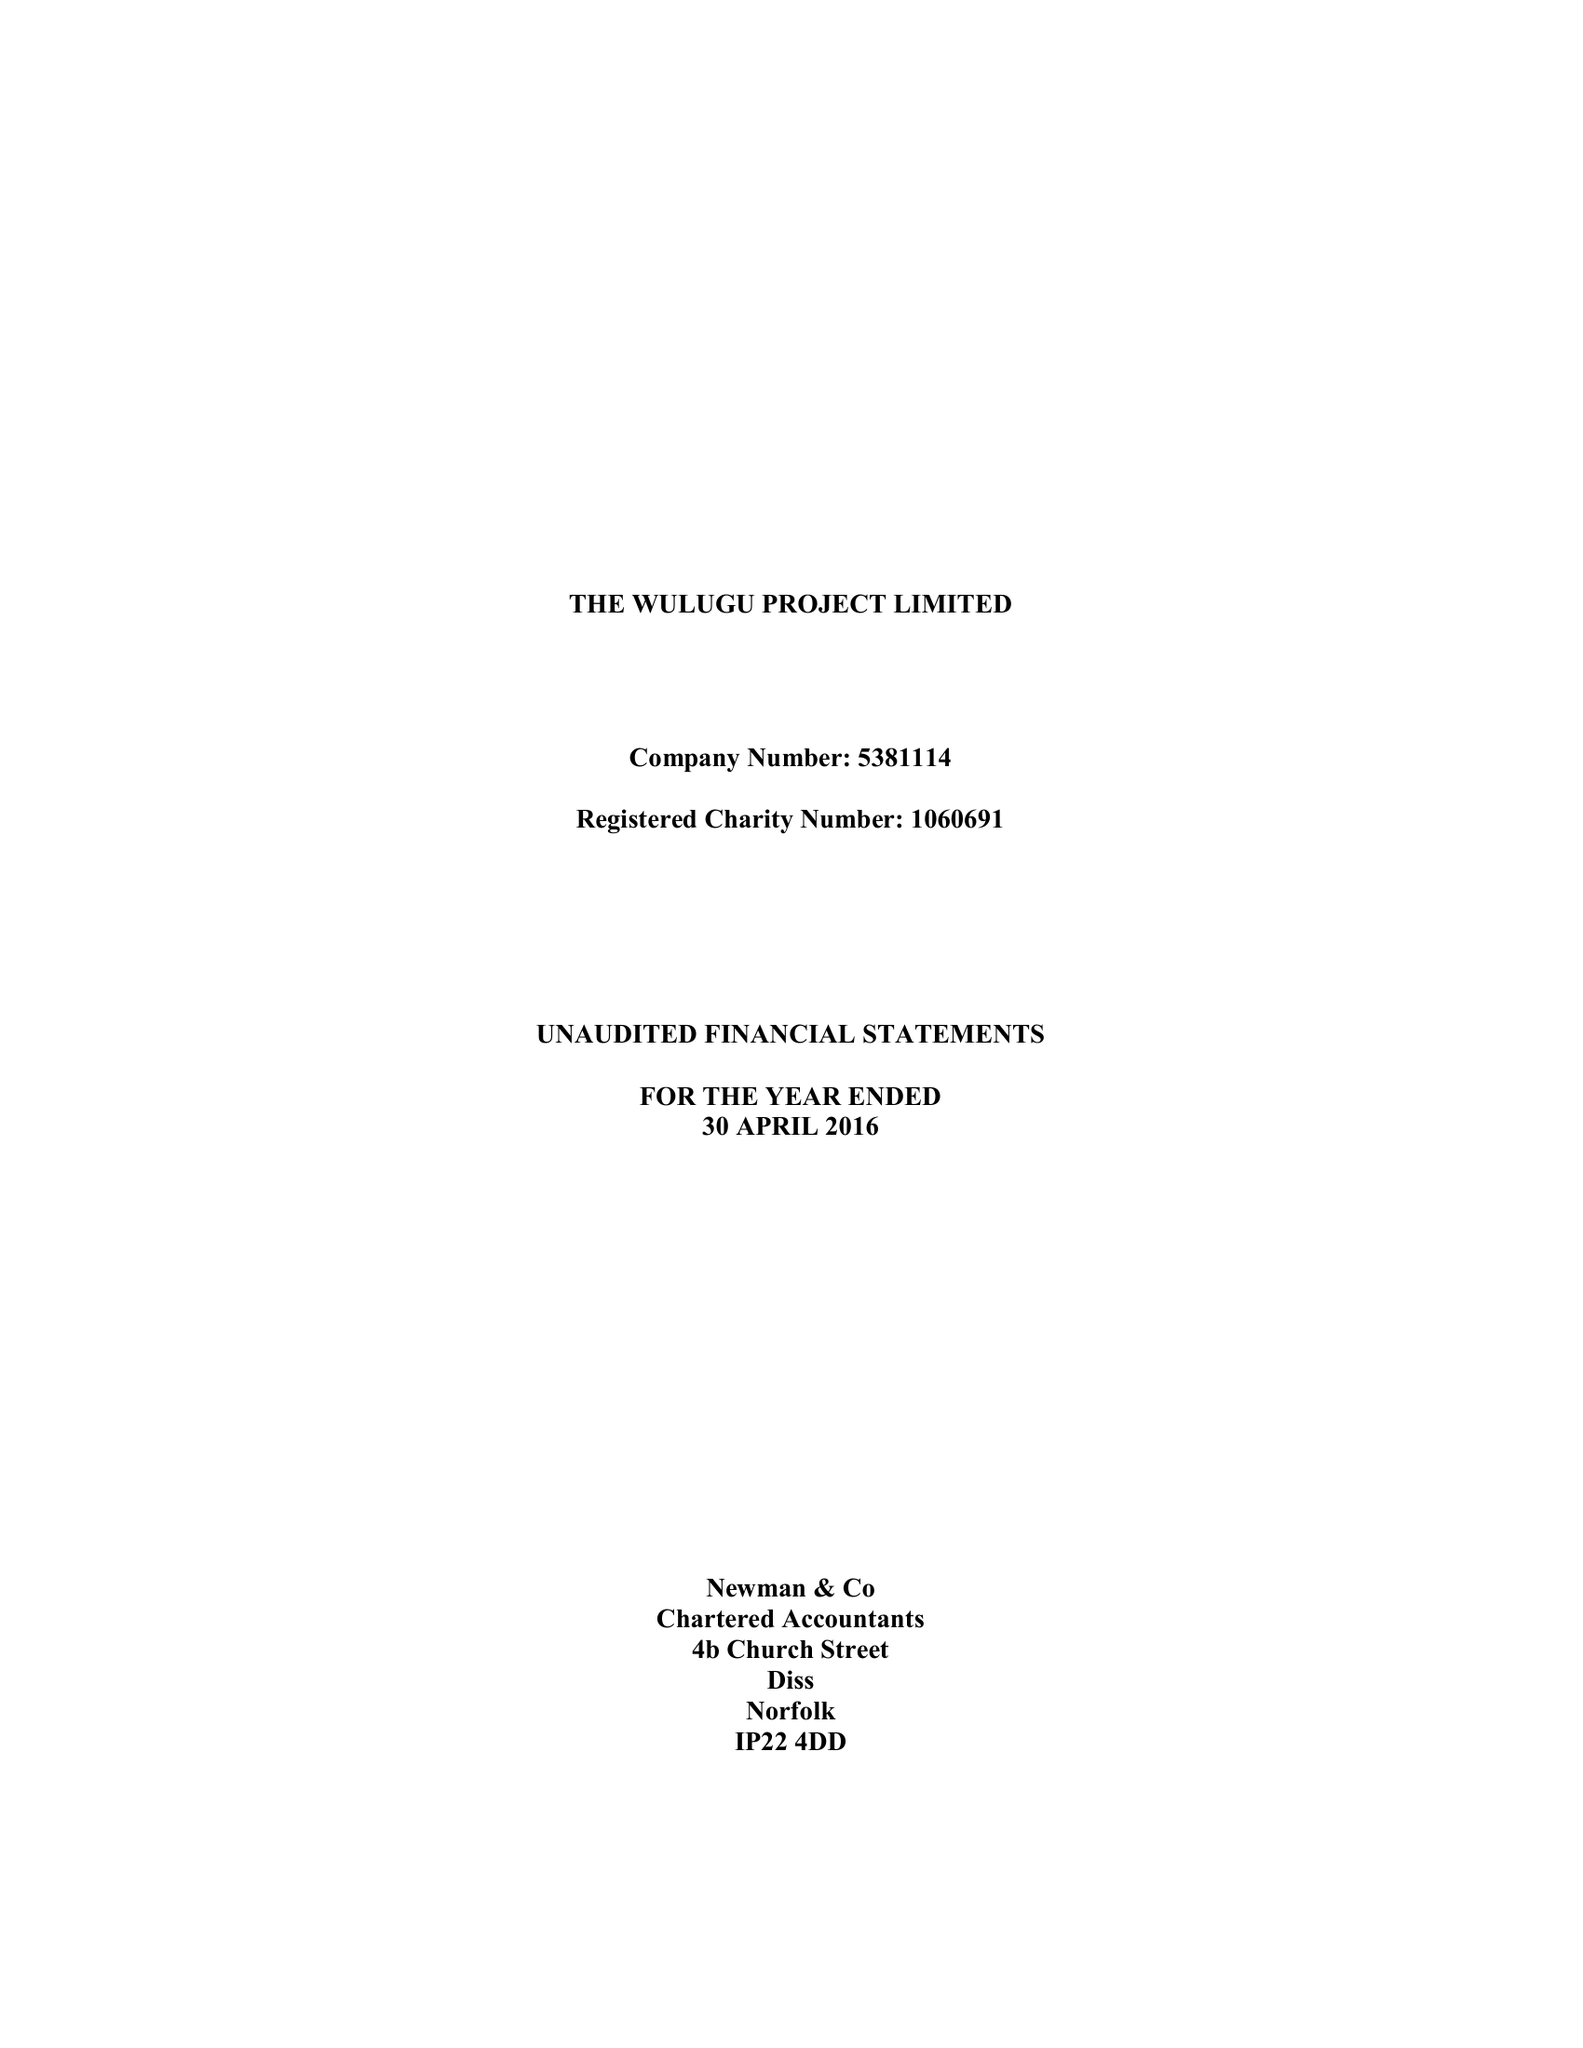What is the value for the spending_annually_in_british_pounds?
Answer the question using a single word or phrase. 133613.00 